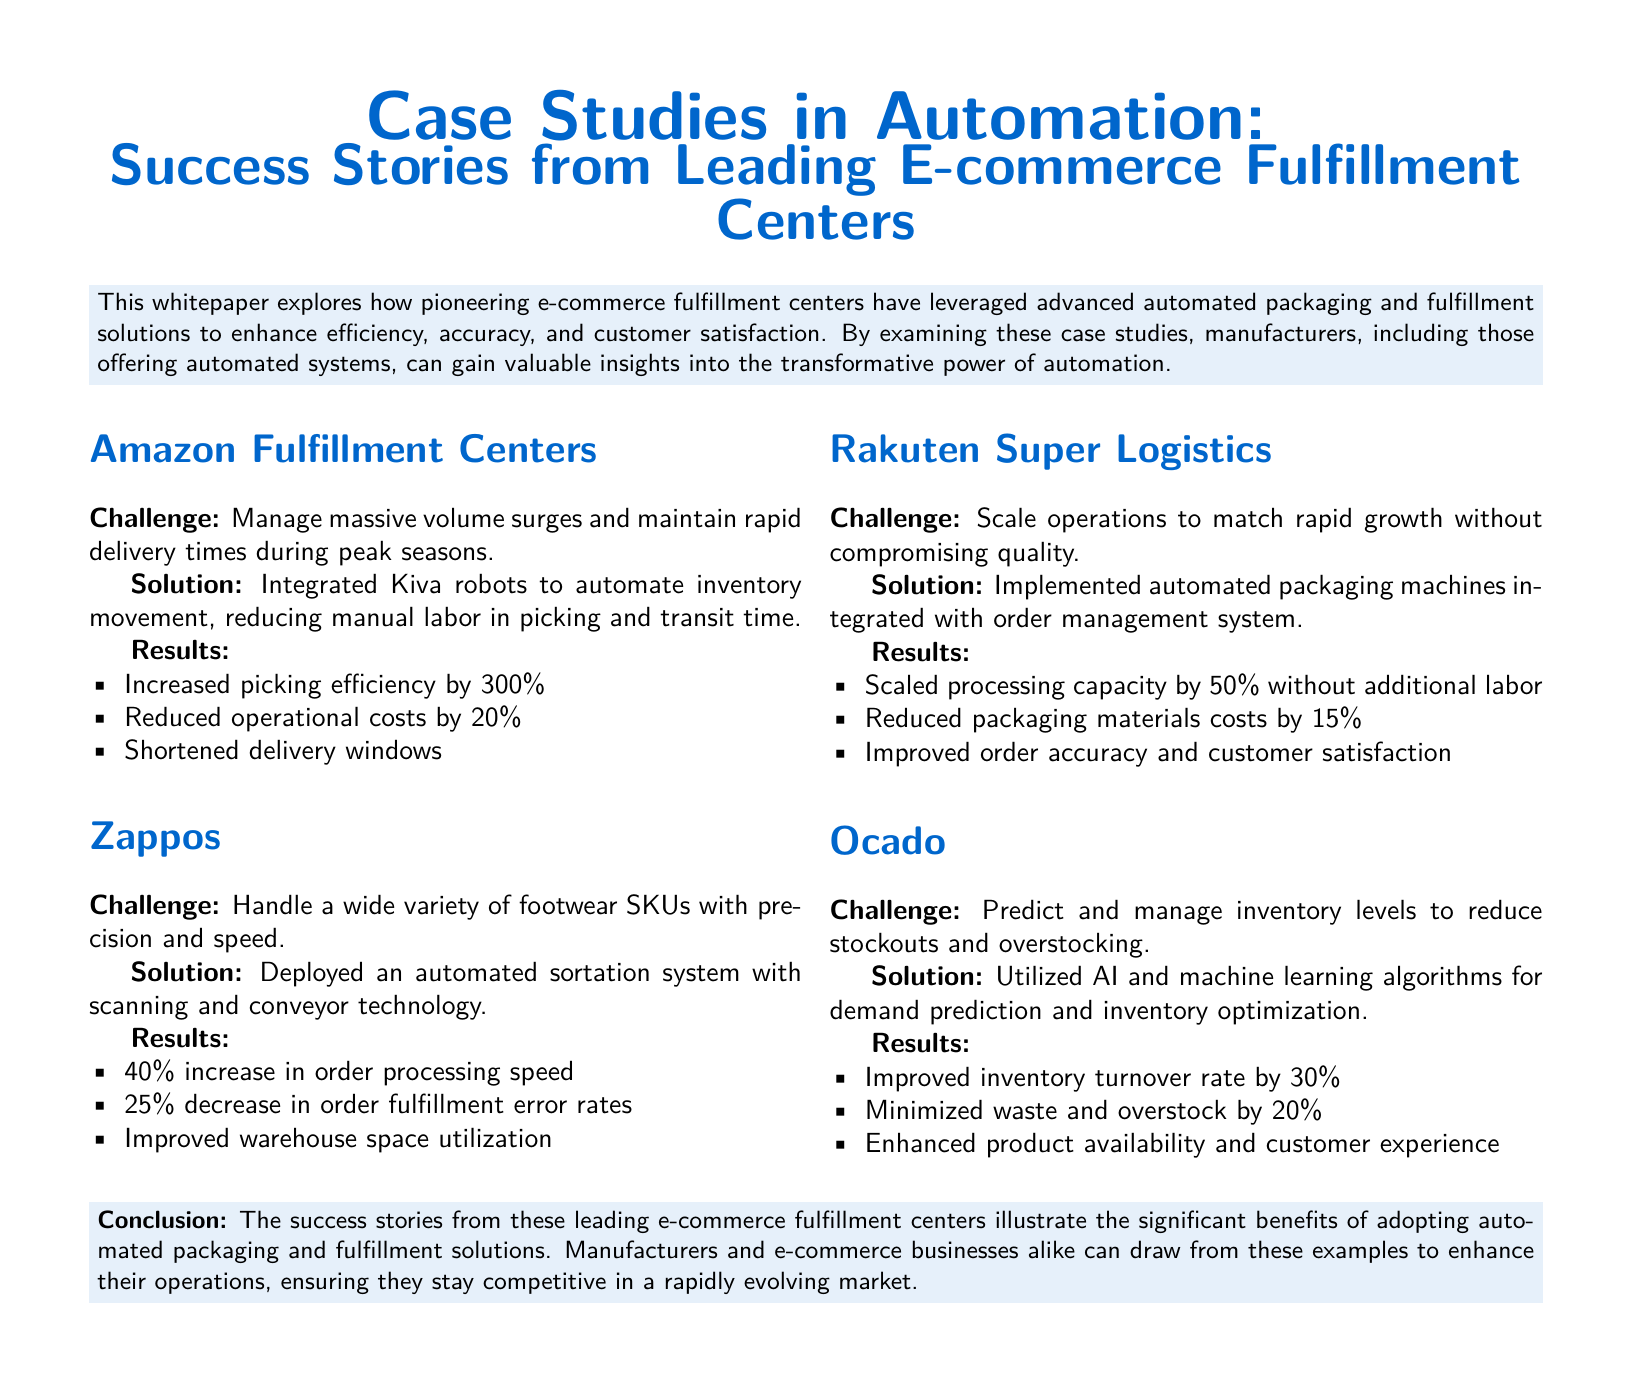What was the challenge faced by Amazon Fulfillment Centers? The challenge was to manage massive volume surges and maintain rapid delivery times during peak seasons.
Answer: Manage massive volume surges and maintain rapid delivery times during peak seasons What technology did Zappos use to improve order processing speed? Zappos deployed an automated sortation system with scanning and conveyor technology.
Answer: Automated sortation system with scanning and conveyor technology What was the result of Rakuten Super Logistics implementing automated packaging machines? They scaled processing capacity by 50% without additional labor.
Answer: Scaled processing capacity by 50% without additional labor How much did Ocado improve its inventory turnover rate? Ocado improved its inventory turnover rate by 30%.
Answer: Improved inventory turnover rate by 30% What was one of the benefits of automation highlighted in the conclusion? The conclusion highlights that automation enhances operations and ensures competitiveness.
Answer: Enhances operations, ensuring competitiveness 